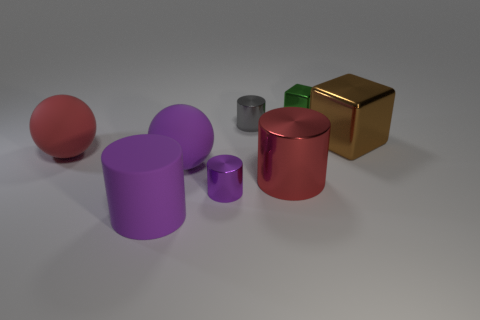What shape is the large thing in front of the big shiny thing that is in front of the large brown object?
Offer a terse response. Cylinder. The matte ball that is the same color as the large rubber cylinder is what size?
Provide a succinct answer. Large. How many green objects are the same shape as the large brown shiny object?
Offer a terse response. 1. What is the color of the tiny thing in front of the gray thing?
Offer a terse response. Purple. What number of rubber objects are big red balls or gray balls?
Provide a short and direct response. 1. What shape is the tiny metal object that is the same color as the big rubber cylinder?
Ensure brevity in your answer.  Cylinder. What number of purple shiny cylinders have the same size as the brown cube?
Give a very brief answer. 0. There is a metallic object that is in front of the green metal cube and right of the big red shiny cylinder; what color is it?
Provide a succinct answer. Brown. What number of objects are either tiny brown spheres or blocks?
Your response must be concise. 2. What number of tiny things are gray metallic objects or things?
Give a very brief answer. 3. 